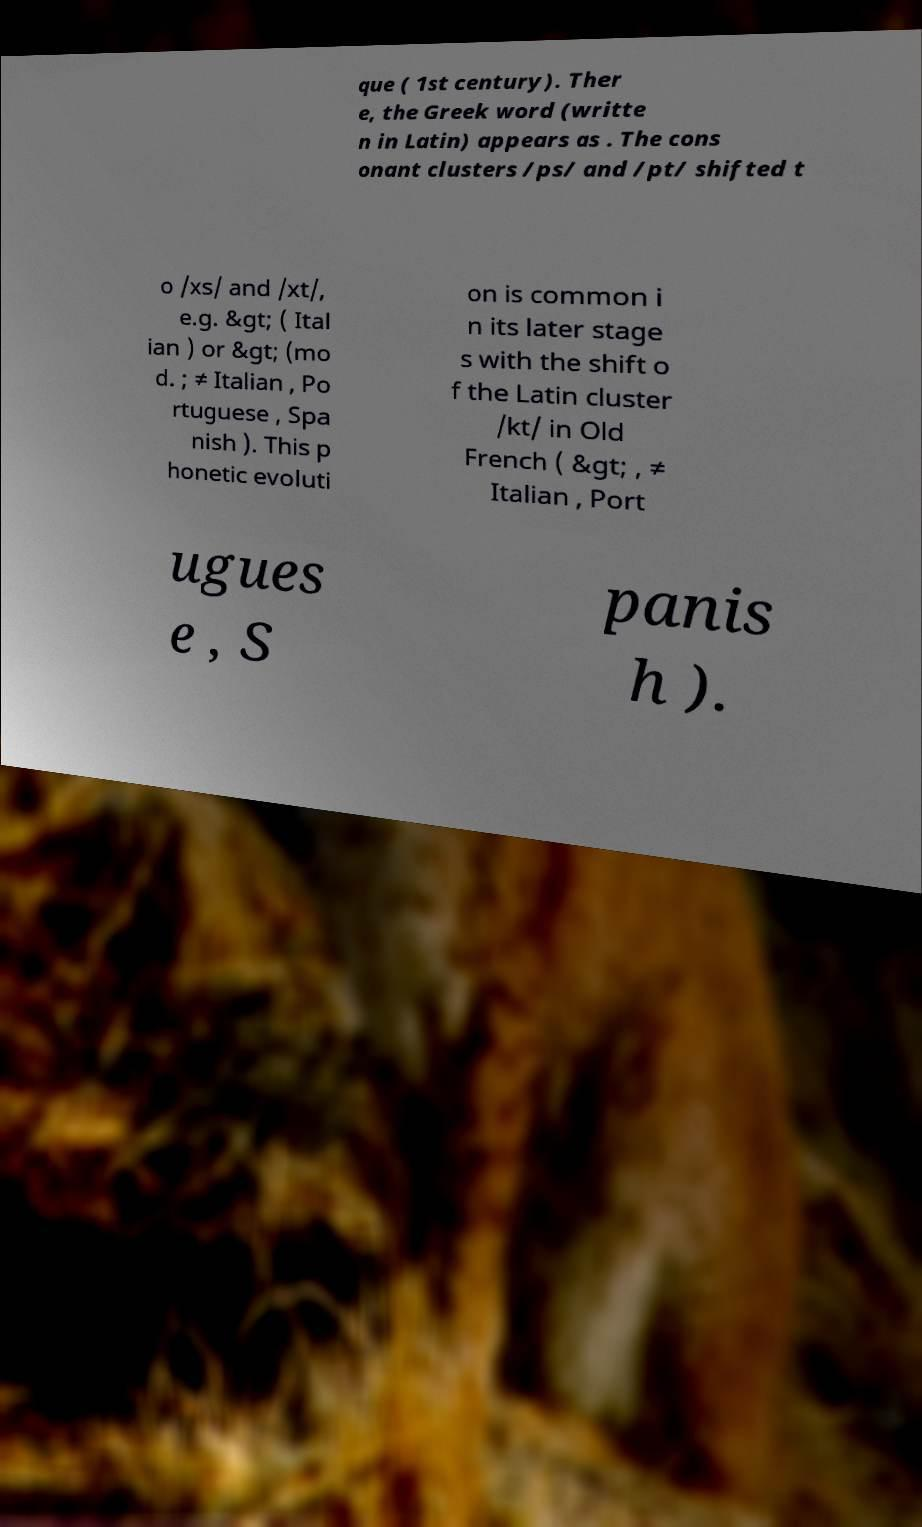Could you assist in decoding the text presented in this image and type it out clearly? que ( 1st century). Ther e, the Greek word (writte n in Latin) appears as . The cons onant clusters /ps/ and /pt/ shifted t o /xs/ and /xt/, e.g. &gt; ( Ital ian ) or &gt; (mo d. ; ≠ Italian , Po rtuguese , Spa nish ). This p honetic evoluti on is common i n its later stage s with the shift o f the Latin cluster /kt/ in Old French ( &gt; , ≠ Italian , Port ugues e , S panis h ). 